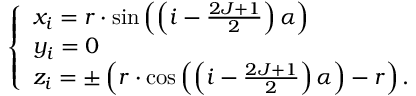<formula> <loc_0><loc_0><loc_500><loc_500>\left \{ \begin{array} { l l } { x _ { i } = r \cdot \sin \left ( \left ( i - \frac { 2 J + 1 } { 2 } \right ) \alpha \right ) } \\ { y _ { i } = 0 } \\ { z _ { i } = \pm \left ( r \cdot \cos \left ( \left ( i - \frac { 2 J + 1 } { 2 } \right ) \alpha \right ) - r \right ) . } \end{array}</formula> 